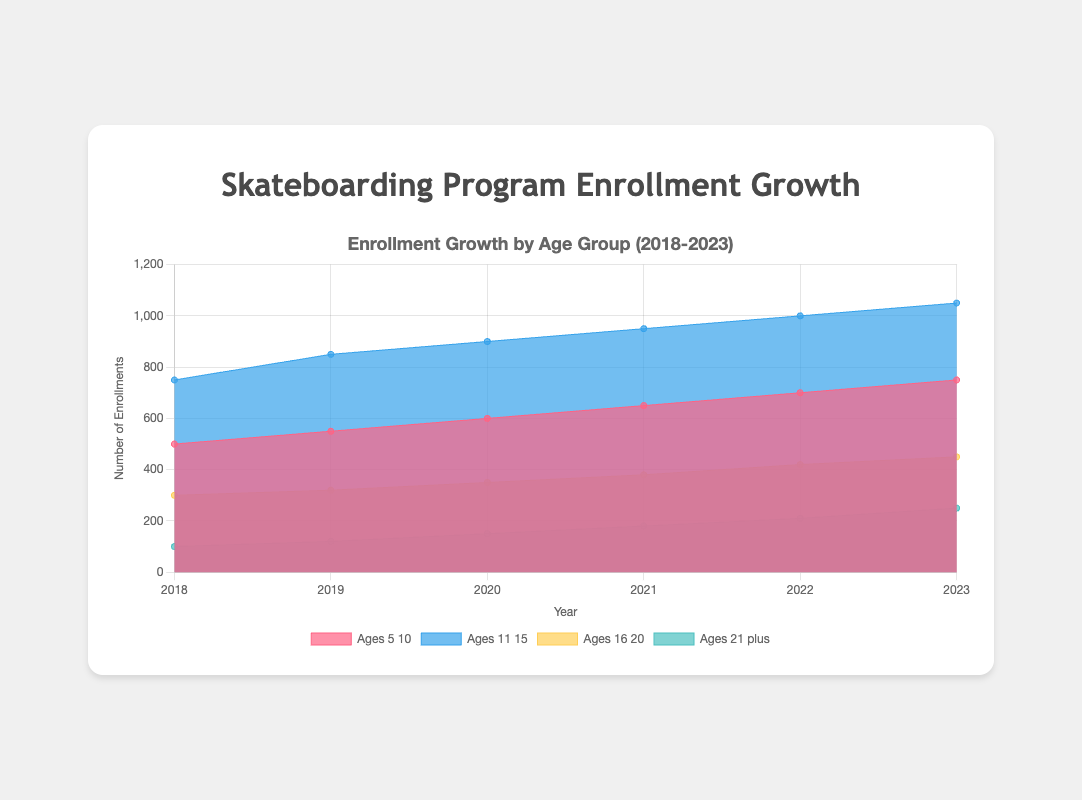How many age groups are displayed in the area chart? The chart shows four different age groups: Ages 5-10, Ages 11-15, Ages 16-20, and Ages 21 plus.
Answer: 4 What is the title of the area chart? The title is usually displayed at the top of the chart and reads "Enrollment Growth by Age Group (2018-2023)".
Answer: Enrollment Growth by Age Group (2018-2023) Which age group showed the highest enrollment in 2023? By looking at the data for 2023, Ages 11-15 has the highest enrollment with 1050 entries.
Answer: Ages 11-15 How has the enrollment for Ages 5-10 changed from 2018 to 2023? The enrollment for Ages 5-10 increased from 500 in 2018 to 750 in 2023. The difference is 750 - 500 = 250.
Answer: Increased by 250 Which year showed the most significant increase in enrollments for Ages 21 plus? By comparing the year-on-year enrollment numbers for Ages 21 plus, the most significant increase occurred between 2022 (210 enrollments) and 2023 (250 enrollments), a jump of 40.
Answer: 2022 to 2023 What is the total enrollment for all age groups combined in 2020? Sum the enrollments for each age group in 2020: 600 (Ages 5-10) + 900 (Ages 11-15) + 350 (Ages 16-20) + 150 (Ages 21 plus) = 2000.
Answer: 2000 Compare the growth in enrollment for Ages 16-20 and Ages 21 plus from 2018 to 2023. Which age group had a higher growth rate? Ages 16-20 grew from 300 to 450 (150 increase), Ages 21 plus grew from 100 to 250 (150 increase). Both groups grew by the same amount, but Ages 21 plus had a higher growth rate relative to its smaller base.
Answer: Ages 21 plus What is the trend in enrollments for Ages 11-15 over the last 5 years? Enrollments for Ages 11-15 consistently increased year over year from 750 in 2018 to 1050 in 2023, indicating a steady upward trend.
Answer: Steady upward trend What is the average enrollment for Ages 16-20 between 2018 and 2023? Calculate the average: (300+320+350+380+420+450)/6 = 370.
Answer: 370 